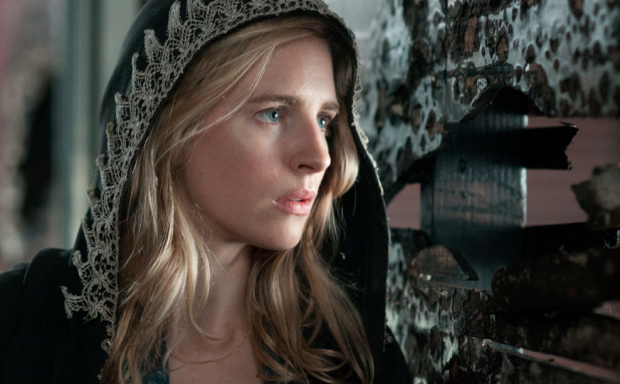What could be the significance of the peeling posters in the backdrop? The peeling posters in the backdrop likely signify the passage of time and the decline of a once-prominent culture or era. They add a sense of history and depth to the scene, hinting at forgotten stories and unresolved conflicts. These posters serve as visual metaphors for the persistence of the past, subtly suggesting that the character might be delving into old mysteries or confronting issues that have been neglected or abandoned. 